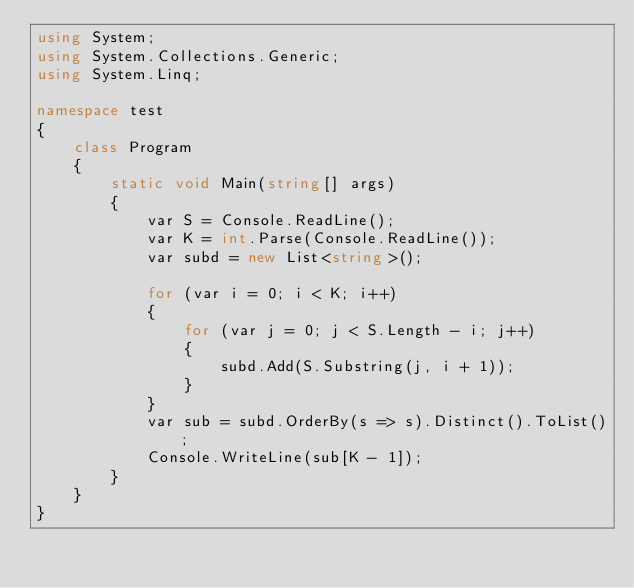Convert code to text. <code><loc_0><loc_0><loc_500><loc_500><_C#_>using System;
using System.Collections.Generic;
using System.Linq;

namespace test
{
    class Program
    {
        static void Main(string[] args)
        {
            var S = Console.ReadLine();
            var K = int.Parse(Console.ReadLine());
            var subd = new List<string>();

            for (var i = 0; i < K; i++)
            {
                for (var j = 0; j < S.Length - i; j++)
                {
                    subd.Add(S.Substring(j, i + 1));
                }
            }
            var sub = subd.OrderBy(s => s).Distinct().ToList();
            Console.WriteLine(sub[K - 1]);
        }
    }
}</code> 